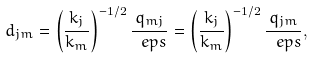<formula> <loc_0><loc_0><loc_500><loc_500>d _ { j m } = \left ( \frac { k _ { j } } { k _ { m } } \right ) ^ { - 1 / 2 } \frac { q _ { m j } } { \ e p s } = \left ( \frac { k _ { j } } { k _ { m } } \right ) ^ { - 1 / 2 } \frac { q _ { j m } } { \ e p s } ,</formula> 